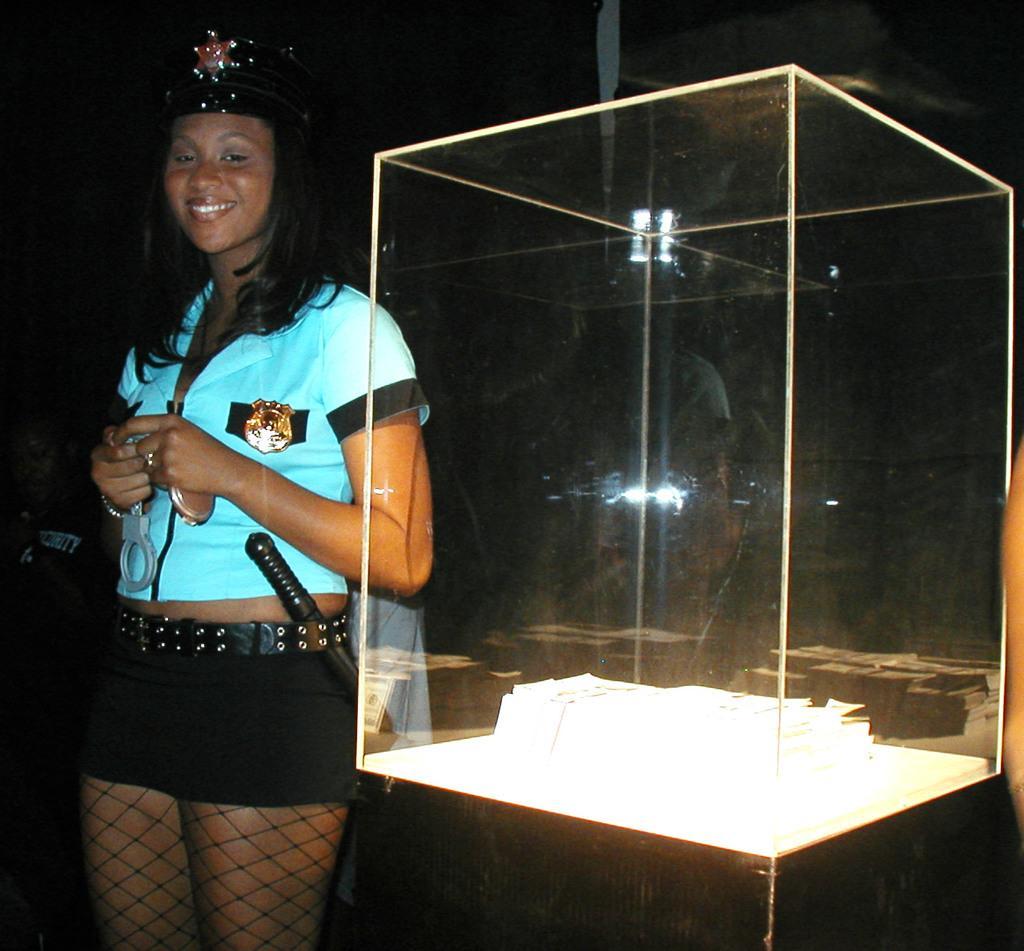Can you describe this image briefly? In this picture we can see a woman wore a cap and standing and smiling, handcuff, glass box and some objects and in the background it is dark. 